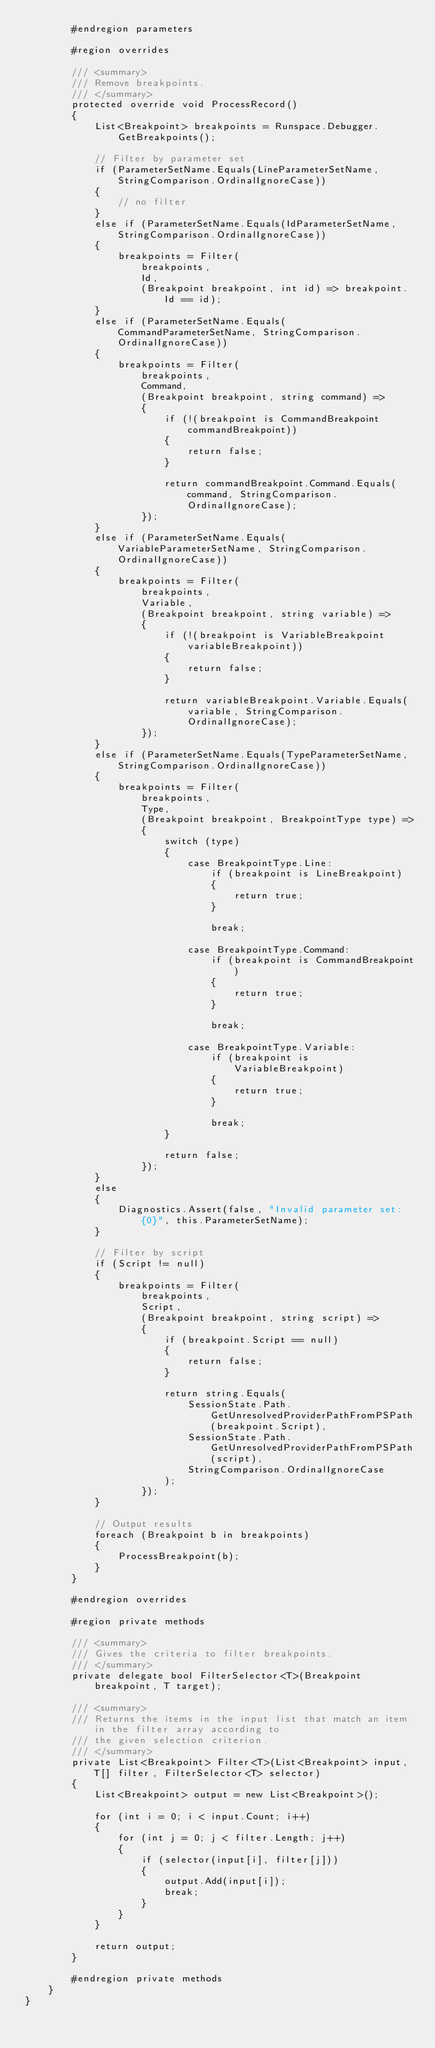Convert code to text. <code><loc_0><loc_0><loc_500><loc_500><_C#_>        #endregion parameters

        #region overrides

        /// <summary>
        /// Remove breakpoints.
        /// </summary>
        protected override void ProcessRecord()
        {
            List<Breakpoint> breakpoints = Runspace.Debugger.GetBreakpoints();

            // Filter by parameter set
            if (ParameterSetName.Equals(LineParameterSetName, StringComparison.OrdinalIgnoreCase))
            {
                // no filter
            }
            else if (ParameterSetName.Equals(IdParameterSetName, StringComparison.OrdinalIgnoreCase))
            {
                breakpoints = Filter(
                    breakpoints,
                    Id,
                    (Breakpoint breakpoint, int id) => breakpoint.Id == id);
            }
            else if (ParameterSetName.Equals(CommandParameterSetName, StringComparison.OrdinalIgnoreCase))
            {
                breakpoints = Filter(
                    breakpoints,
                    Command,
                    (Breakpoint breakpoint, string command) =>
                    {
                        if (!(breakpoint is CommandBreakpoint commandBreakpoint))
                        {
                            return false;
                        }

                        return commandBreakpoint.Command.Equals(command, StringComparison.OrdinalIgnoreCase);
                    });
            }
            else if (ParameterSetName.Equals(VariableParameterSetName, StringComparison.OrdinalIgnoreCase))
            {
                breakpoints = Filter(
                    breakpoints,
                    Variable,
                    (Breakpoint breakpoint, string variable) =>
                    {
                        if (!(breakpoint is VariableBreakpoint variableBreakpoint))
                        {
                            return false;
                        }

                        return variableBreakpoint.Variable.Equals(variable, StringComparison.OrdinalIgnoreCase);
                    });
            }
            else if (ParameterSetName.Equals(TypeParameterSetName, StringComparison.OrdinalIgnoreCase))
            {
                breakpoints = Filter(
                    breakpoints,
                    Type,
                    (Breakpoint breakpoint, BreakpointType type) =>
                    {
                        switch (type)
                        {
                            case BreakpointType.Line:
                                if (breakpoint is LineBreakpoint)
                                {
                                    return true;
                                }

                                break;

                            case BreakpointType.Command:
                                if (breakpoint is CommandBreakpoint)
                                {
                                    return true;
                                }

                                break;

                            case BreakpointType.Variable:
                                if (breakpoint is VariableBreakpoint)
                                {
                                    return true;
                                }

                                break;
                        }

                        return false;
                    });
            }
            else
            {
                Diagnostics.Assert(false, "Invalid parameter set: {0}", this.ParameterSetName);
            }

            // Filter by script
            if (Script != null)
            {
                breakpoints = Filter(
                    breakpoints,
                    Script,
                    (Breakpoint breakpoint, string script) =>
                    {
                        if (breakpoint.Script == null)
                        {
                            return false;
                        }

                        return string.Equals(
                            SessionState.Path.GetUnresolvedProviderPathFromPSPath(breakpoint.Script),
                            SessionState.Path.GetUnresolvedProviderPathFromPSPath(script),
                            StringComparison.OrdinalIgnoreCase
                        );
                    });
            }

            // Output results
            foreach (Breakpoint b in breakpoints)
            {
                ProcessBreakpoint(b);
            }
        }

        #endregion overrides

        #region private methods

        /// <summary>
        /// Gives the criteria to filter breakpoints.
        /// </summary>
        private delegate bool FilterSelector<T>(Breakpoint breakpoint, T target);

        /// <summary>
        /// Returns the items in the input list that match an item in the filter array according to
        /// the given selection criterion.
        /// </summary>
        private List<Breakpoint> Filter<T>(List<Breakpoint> input, T[] filter, FilterSelector<T> selector)
        {
            List<Breakpoint> output = new List<Breakpoint>();

            for (int i = 0; i < input.Count; i++)
            {
                for (int j = 0; j < filter.Length; j++)
                {
                    if (selector(input[i], filter[j]))
                    {
                        output.Add(input[i]);
                        break;
                    }
                }
            }

            return output;
        }

        #endregion private methods
    }
}
</code> 